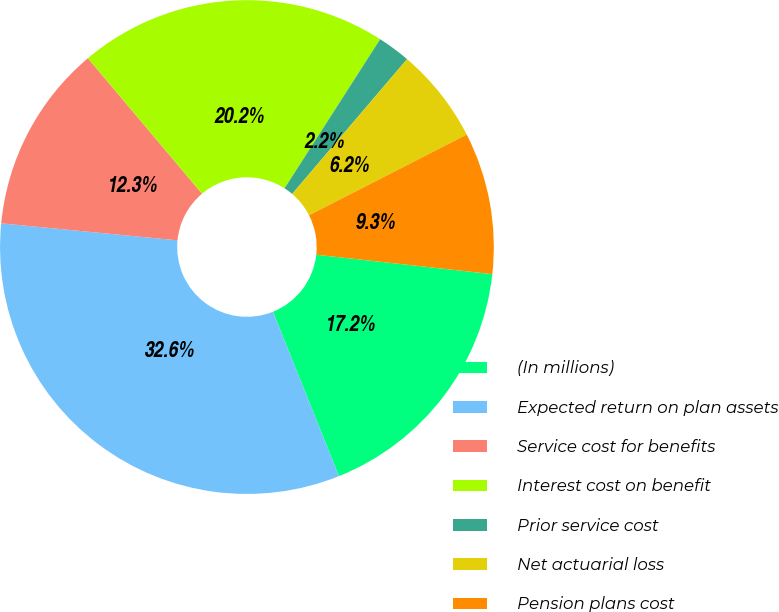<chart> <loc_0><loc_0><loc_500><loc_500><pie_chart><fcel>(In millions)<fcel>Expected return on plan assets<fcel>Service cost for benefits<fcel>Interest cost on benefit<fcel>Prior service cost<fcel>Net actuarial loss<fcel>Pension plans cost<nl><fcel>17.17%<fcel>32.61%<fcel>12.33%<fcel>20.21%<fcel>2.16%<fcel>6.24%<fcel>9.28%<nl></chart> 